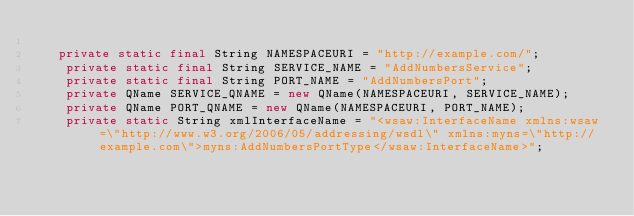<code> <loc_0><loc_0><loc_500><loc_500><_Java_>
   private static final String NAMESPACEURI = "http://example.com/";
    private static final String SERVICE_NAME = "AddNumbersService";
    private static final String PORT_NAME = "AddNumbersPort";
    private QName SERVICE_QNAME = new QName(NAMESPACEURI, SERVICE_NAME);
    private QName PORT_QNAME = new QName(NAMESPACEURI, PORT_NAME);
    private static String xmlInterfaceName = "<wsaw:InterfaceName xmlns:wsaw=\"http://www.w3.org/2006/05/addressing/wsdl\" xmlns:myns=\"http://example.com\">myns:AddNumbersPortType</wsaw:InterfaceName>";
</code> 